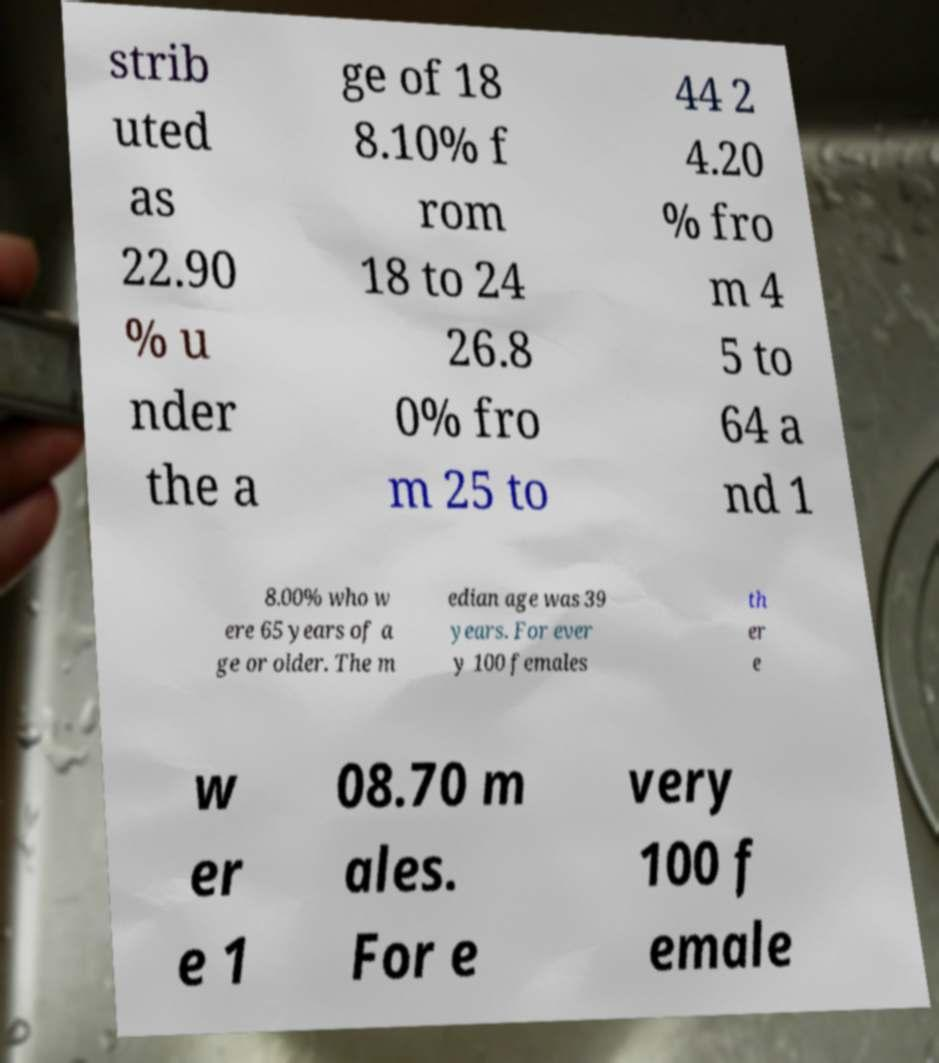Can you accurately transcribe the text from the provided image for me? strib uted as 22.90 % u nder the a ge of 18 8.10% f rom 18 to 24 26.8 0% fro m 25 to 44 2 4.20 % fro m 4 5 to 64 a nd 1 8.00% who w ere 65 years of a ge or older. The m edian age was 39 years. For ever y 100 females th er e w er e 1 08.70 m ales. For e very 100 f emale 